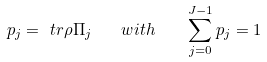<formula> <loc_0><loc_0><loc_500><loc_500>p _ { j } = \ t r { \rho \Pi _ { j } } \quad w i t h \quad \sum _ { j = 0 } ^ { J - 1 } p _ { j } = 1</formula> 